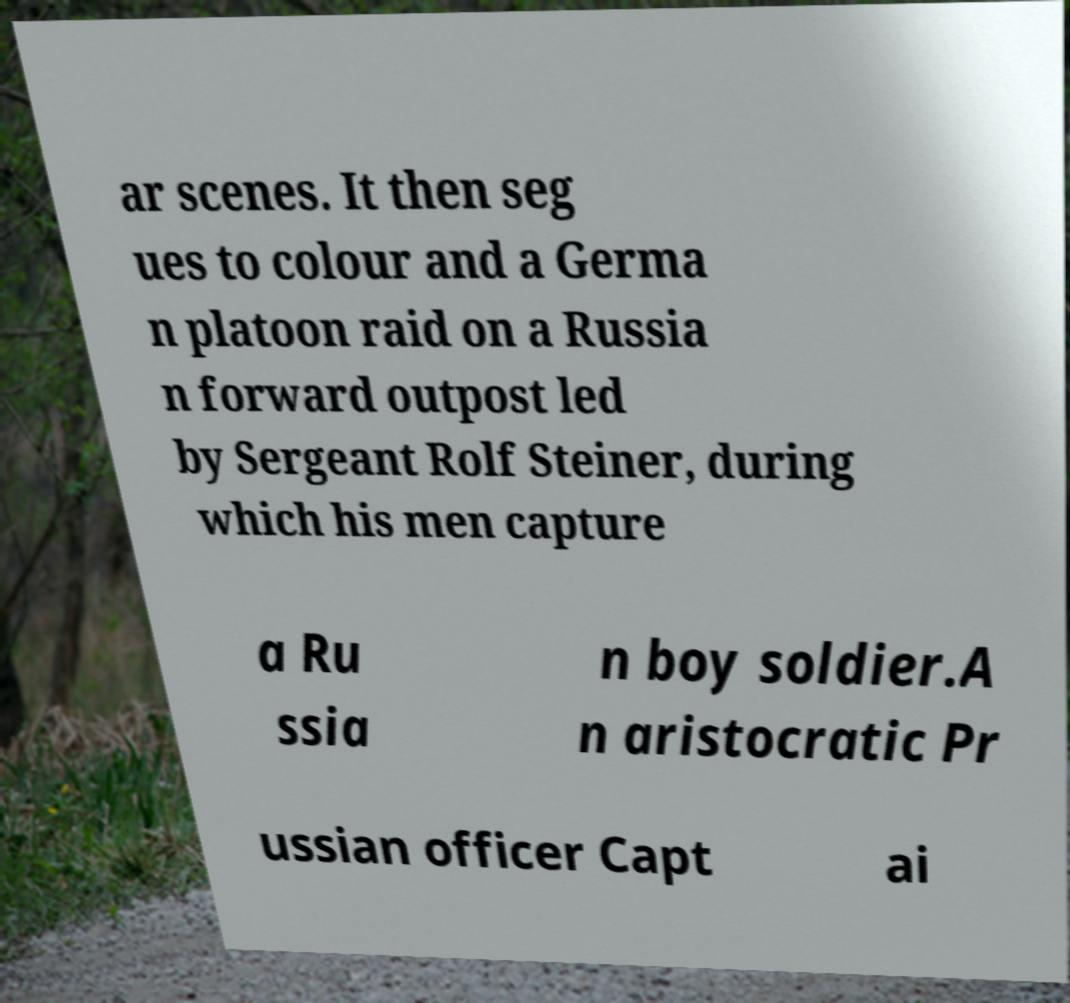Please identify and transcribe the text found in this image. ar scenes. It then seg ues to colour and a Germa n platoon raid on a Russia n forward outpost led by Sergeant Rolf Steiner, during which his men capture a Ru ssia n boy soldier.A n aristocratic Pr ussian officer Capt ai 